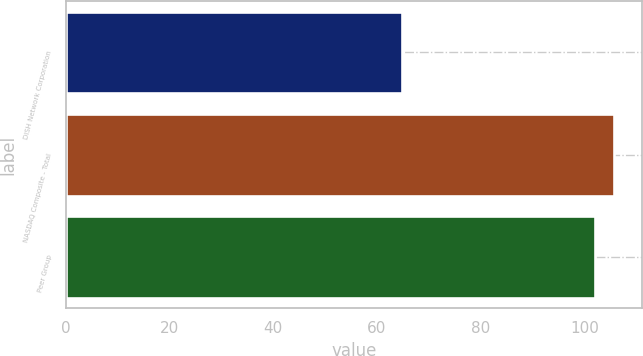<chart> <loc_0><loc_0><loc_500><loc_500><bar_chart><fcel>DISH Network Corporation<fcel>NASDAQ Composite - Total<fcel>Peer Group<nl><fcel>64.77<fcel>105.77<fcel>101.94<nl></chart> 